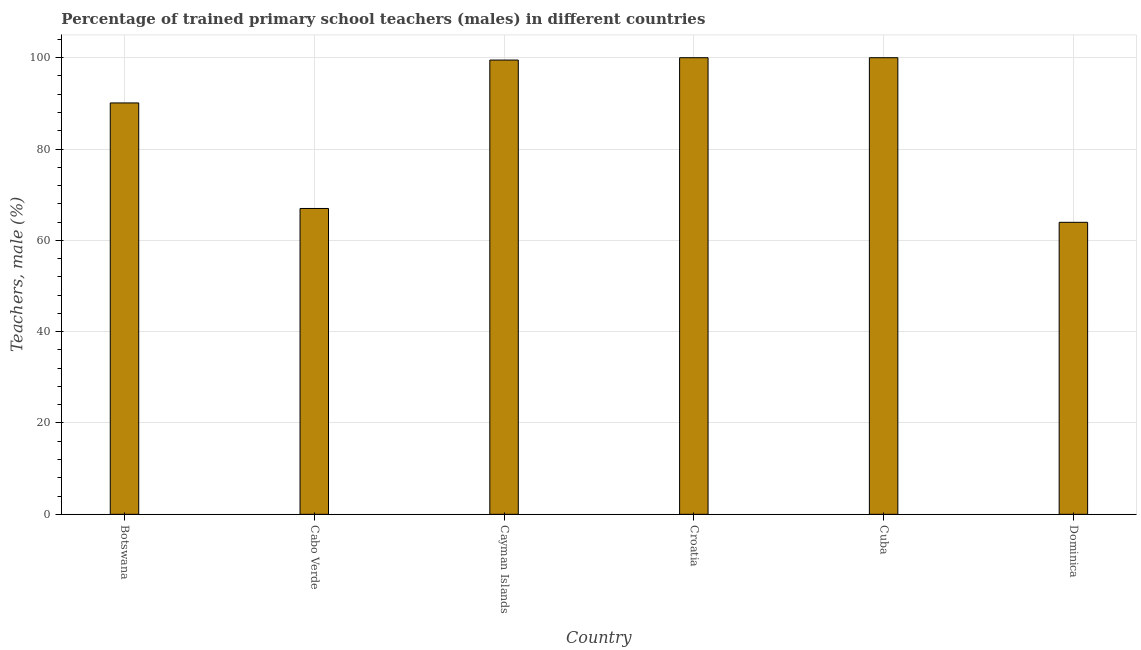Does the graph contain any zero values?
Offer a very short reply. No. Does the graph contain grids?
Offer a very short reply. Yes. What is the title of the graph?
Your response must be concise. Percentage of trained primary school teachers (males) in different countries. What is the label or title of the X-axis?
Keep it short and to the point. Country. What is the label or title of the Y-axis?
Keep it short and to the point. Teachers, male (%). Across all countries, what is the minimum percentage of trained male teachers?
Keep it short and to the point. 63.95. In which country was the percentage of trained male teachers maximum?
Offer a terse response. Croatia. In which country was the percentage of trained male teachers minimum?
Make the answer very short. Dominica. What is the sum of the percentage of trained male teachers?
Provide a short and direct response. 520.51. What is the difference between the percentage of trained male teachers in Cabo Verde and Cayman Islands?
Make the answer very short. -32.5. What is the average percentage of trained male teachers per country?
Your answer should be very brief. 86.75. What is the median percentage of trained male teachers?
Offer a very short reply. 94.79. What is the ratio of the percentage of trained male teachers in Cuba to that in Dominica?
Give a very brief answer. 1.56. Is the difference between the percentage of trained male teachers in Cabo Verde and Cuba greater than the difference between any two countries?
Make the answer very short. No. What is the difference between the highest and the second highest percentage of trained male teachers?
Your answer should be very brief. 0. What is the difference between the highest and the lowest percentage of trained male teachers?
Give a very brief answer. 36.05. Are all the bars in the graph horizontal?
Make the answer very short. No. How many countries are there in the graph?
Your answer should be compact. 6. What is the difference between two consecutive major ticks on the Y-axis?
Provide a short and direct response. 20. Are the values on the major ticks of Y-axis written in scientific E-notation?
Provide a succinct answer. No. What is the Teachers, male (%) in Botswana?
Keep it short and to the point. 90.09. What is the Teachers, male (%) in Cabo Verde?
Offer a very short reply. 66.98. What is the Teachers, male (%) of Cayman Islands?
Your answer should be compact. 99.48. What is the Teachers, male (%) in Croatia?
Your response must be concise. 100. What is the Teachers, male (%) of Dominica?
Your response must be concise. 63.95. What is the difference between the Teachers, male (%) in Botswana and Cabo Verde?
Your answer should be compact. 23.11. What is the difference between the Teachers, male (%) in Botswana and Cayman Islands?
Make the answer very short. -9.39. What is the difference between the Teachers, male (%) in Botswana and Croatia?
Make the answer very short. -9.91. What is the difference between the Teachers, male (%) in Botswana and Cuba?
Give a very brief answer. -9.91. What is the difference between the Teachers, male (%) in Botswana and Dominica?
Your response must be concise. 26.15. What is the difference between the Teachers, male (%) in Cabo Verde and Cayman Islands?
Ensure brevity in your answer.  -32.5. What is the difference between the Teachers, male (%) in Cabo Verde and Croatia?
Your answer should be very brief. -33.02. What is the difference between the Teachers, male (%) in Cabo Verde and Cuba?
Provide a succinct answer. -33.02. What is the difference between the Teachers, male (%) in Cabo Verde and Dominica?
Offer a very short reply. 3.03. What is the difference between the Teachers, male (%) in Cayman Islands and Croatia?
Your answer should be very brief. -0.52. What is the difference between the Teachers, male (%) in Cayman Islands and Cuba?
Provide a short and direct response. -0.52. What is the difference between the Teachers, male (%) in Cayman Islands and Dominica?
Offer a terse response. 35.54. What is the difference between the Teachers, male (%) in Croatia and Cuba?
Ensure brevity in your answer.  0. What is the difference between the Teachers, male (%) in Croatia and Dominica?
Make the answer very short. 36.05. What is the difference between the Teachers, male (%) in Cuba and Dominica?
Give a very brief answer. 36.05. What is the ratio of the Teachers, male (%) in Botswana to that in Cabo Verde?
Your response must be concise. 1.34. What is the ratio of the Teachers, male (%) in Botswana to that in Cayman Islands?
Your answer should be very brief. 0.91. What is the ratio of the Teachers, male (%) in Botswana to that in Croatia?
Make the answer very short. 0.9. What is the ratio of the Teachers, male (%) in Botswana to that in Cuba?
Keep it short and to the point. 0.9. What is the ratio of the Teachers, male (%) in Botswana to that in Dominica?
Give a very brief answer. 1.41. What is the ratio of the Teachers, male (%) in Cabo Verde to that in Cayman Islands?
Keep it short and to the point. 0.67. What is the ratio of the Teachers, male (%) in Cabo Verde to that in Croatia?
Keep it short and to the point. 0.67. What is the ratio of the Teachers, male (%) in Cabo Verde to that in Cuba?
Make the answer very short. 0.67. What is the ratio of the Teachers, male (%) in Cabo Verde to that in Dominica?
Offer a terse response. 1.05. What is the ratio of the Teachers, male (%) in Cayman Islands to that in Cuba?
Provide a short and direct response. 0.99. What is the ratio of the Teachers, male (%) in Cayman Islands to that in Dominica?
Your answer should be very brief. 1.56. What is the ratio of the Teachers, male (%) in Croatia to that in Cuba?
Provide a succinct answer. 1. What is the ratio of the Teachers, male (%) in Croatia to that in Dominica?
Keep it short and to the point. 1.56. What is the ratio of the Teachers, male (%) in Cuba to that in Dominica?
Offer a very short reply. 1.56. 